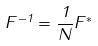<formula> <loc_0><loc_0><loc_500><loc_500>F ^ { - 1 } = \frac { 1 } { N } F ^ { * }</formula> 